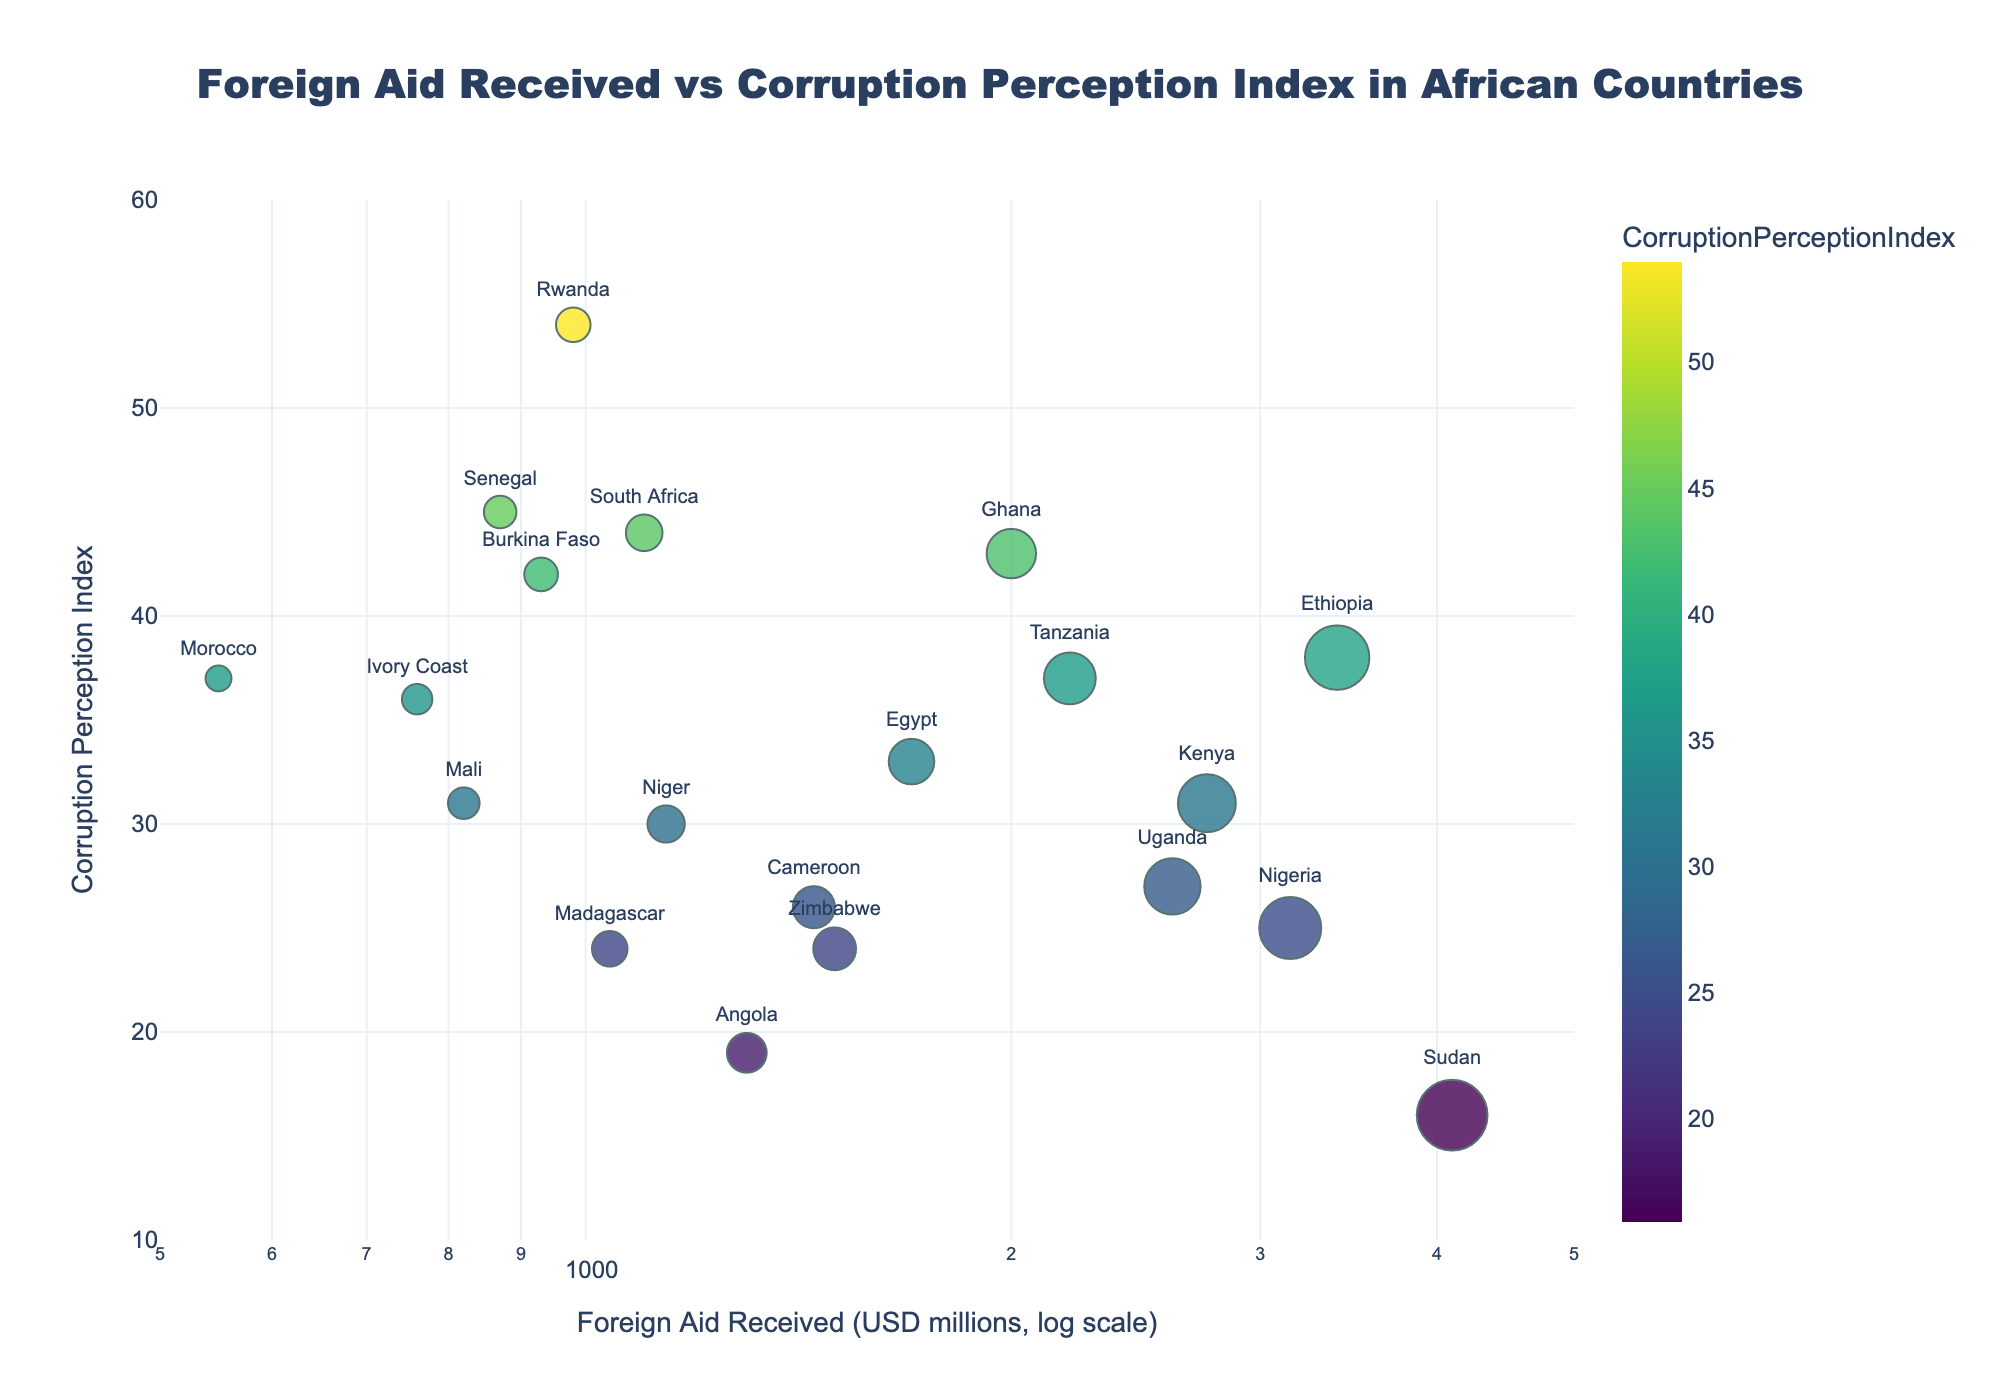What is the title of the figure? The title of the figure is prominently displayed at the top, typically in a larger and bold font, making it easy to identify.
Answer: Foreign Aid Received vs Corruption Perception Index in African Countries What are the units used for the x-axis? The x-axis represents "Foreign Aid Received" in units of millions of USD, as indicated by the label on the axis.
Answer: USD millions Which country received the highest amount of foreign aid? Observing the largest circle and its corresponding tooltip or label, we identify that Sudan received the highest amount of foreign aid.
Answer: Sudan What is the range of the Corruption Perception Index in the figure? The range of the Corruption Perception Index can be identified by looking at the minimum and maximum values on the y-axis, which range from 10 to 60.
Answer: 10 to 60 How many countries received less than 1000 million USD in foreign aid? By looking at the smaller circles and their labels, we can identify that Rwanda, Morocco, Senegal, and Ivory Coast received less than 1000 million USD in foreign aid. Counting these countries gives a total of 4.
Answer: 4 Which country has the highest Corruption Perception Index? By looking for the highest point on the y-axis, we identify that Rwanda has the highest Corruption Perception Index.
Answer: Rwanda What is the correlation between foreign aid received and corruption perception index in this figure? By observing the scatter plot layout, it's evident that there is no clear correlation—countries with both high and low values of foreign aid received have varying corruption perception indices. A more analytical approach would require statistical calculations.
Answer: No clear correlation Compare the corruption perception index of Ethiopia and South Africa. Which country has a higher index? By locating the positions of Ethiopia and South Africa on the y-axis, we can see that South Africa has a higher Corruption Perception Index than Ethiopia.
Answer: South Africa Which country with a corruption perception index of less than 20 received the most foreign aid? By identifying the countries with a corruption perception index of less than 20 and then comparing their foreign aid received, we see that Sudan received the most aid among them.
Answer: Sudan What is the approximate median value of the corruption perception index for these countries? To find the median value, we list the corruption perception index values in ascending order and identify the middle value. Given that there are 20 countries, the median will be the average of the 10th and 11th values: (31 + 33)/2 = 32.
Answer: 32 